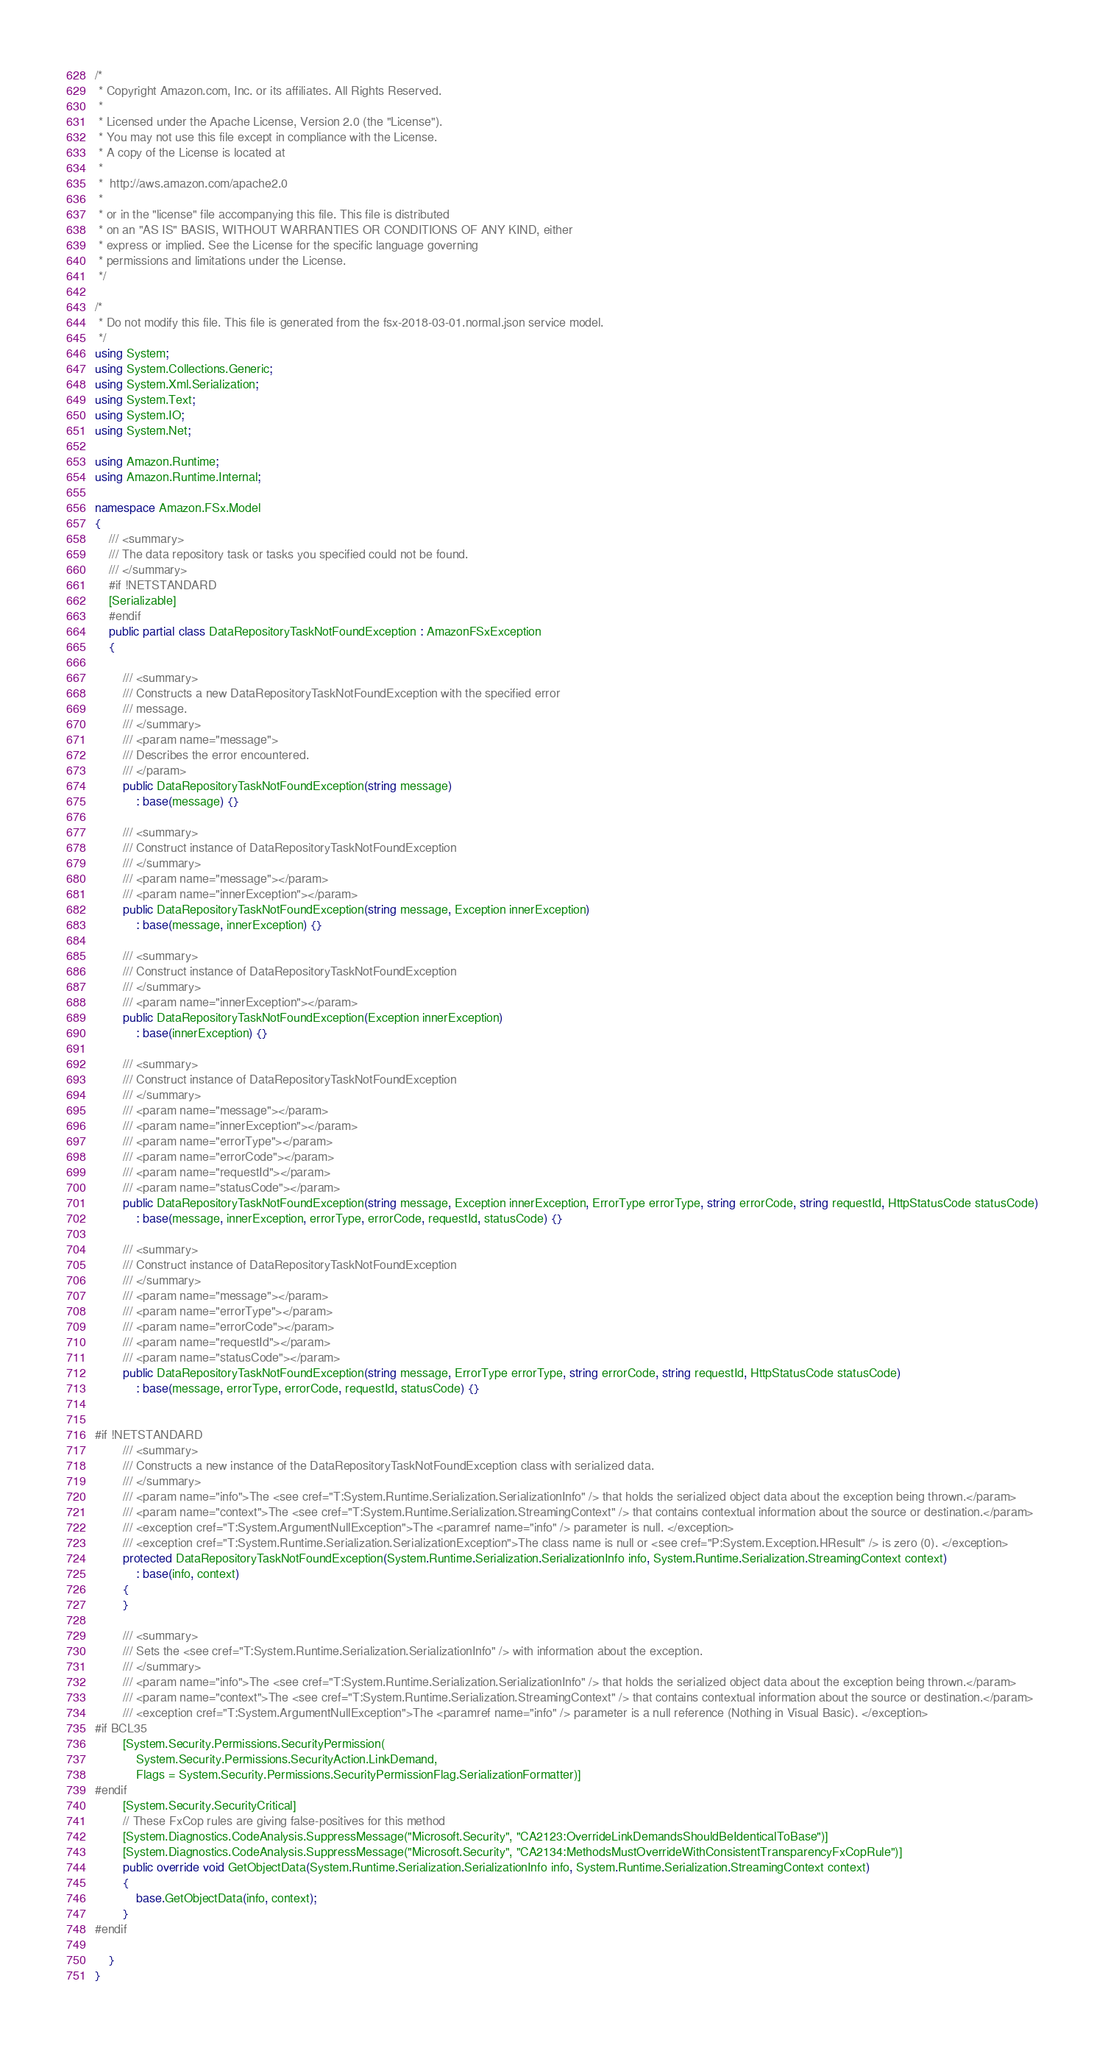Convert code to text. <code><loc_0><loc_0><loc_500><loc_500><_C#_>/*
 * Copyright Amazon.com, Inc. or its affiliates. All Rights Reserved.
 * 
 * Licensed under the Apache License, Version 2.0 (the "License").
 * You may not use this file except in compliance with the License.
 * A copy of the License is located at
 * 
 *  http://aws.amazon.com/apache2.0
 * 
 * or in the "license" file accompanying this file. This file is distributed
 * on an "AS IS" BASIS, WITHOUT WARRANTIES OR CONDITIONS OF ANY KIND, either
 * express or implied. See the License for the specific language governing
 * permissions and limitations under the License.
 */

/*
 * Do not modify this file. This file is generated from the fsx-2018-03-01.normal.json service model.
 */
using System;
using System.Collections.Generic;
using System.Xml.Serialization;
using System.Text;
using System.IO;
using System.Net;

using Amazon.Runtime;
using Amazon.Runtime.Internal;

namespace Amazon.FSx.Model
{
    /// <summary>
    /// The data repository task or tasks you specified could not be found.
    /// </summary>
    #if !NETSTANDARD
    [Serializable]
    #endif
    public partial class DataRepositoryTaskNotFoundException : AmazonFSxException
    {

        /// <summary>
        /// Constructs a new DataRepositoryTaskNotFoundException with the specified error
        /// message.
        /// </summary>
        /// <param name="message">
        /// Describes the error encountered.
        /// </param>
        public DataRepositoryTaskNotFoundException(string message) 
            : base(message) {}

        /// <summary>
        /// Construct instance of DataRepositoryTaskNotFoundException
        /// </summary>
        /// <param name="message"></param>
        /// <param name="innerException"></param>
        public DataRepositoryTaskNotFoundException(string message, Exception innerException) 
            : base(message, innerException) {}

        /// <summary>
        /// Construct instance of DataRepositoryTaskNotFoundException
        /// </summary>
        /// <param name="innerException"></param>
        public DataRepositoryTaskNotFoundException(Exception innerException) 
            : base(innerException) {}

        /// <summary>
        /// Construct instance of DataRepositoryTaskNotFoundException
        /// </summary>
        /// <param name="message"></param>
        /// <param name="innerException"></param>
        /// <param name="errorType"></param>
        /// <param name="errorCode"></param>
        /// <param name="requestId"></param>
        /// <param name="statusCode"></param>
        public DataRepositoryTaskNotFoundException(string message, Exception innerException, ErrorType errorType, string errorCode, string requestId, HttpStatusCode statusCode) 
            : base(message, innerException, errorType, errorCode, requestId, statusCode) {}

        /// <summary>
        /// Construct instance of DataRepositoryTaskNotFoundException
        /// </summary>
        /// <param name="message"></param>
        /// <param name="errorType"></param>
        /// <param name="errorCode"></param>
        /// <param name="requestId"></param>
        /// <param name="statusCode"></param>
        public DataRepositoryTaskNotFoundException(string message, ErrorType errorType, string errorCode, string requestId, HttpStatusCode statusCode) 
            : base(message, errorType, errorCode, requestId, statusCode) {}


#if !NETSTANDARD
        /// <summary>
        /// Constructs a new instance of the DataRepositoryTaskNotFoundException class with serialized data.
        /// </summary>
        /// <param name="info">The <see cref="T:System.Runtime.Serialization.SerializationInfo" /> that holds the serialized object data about the exception being thrown.</param>
        /// <param name="context">The <see cref="T:System.Runtime.Serialization.StreamingContext" /> that contains contextual information about the source or destination.</param>
        /// <exception cref="T:System.ArgumentNullException">The <paramref name="info" /> parameter is null. </exception>
        /// <exception cref="T:System.Runtime.Serialization.SerializationException">The class name is null or <see cref="P:System.Exception.HResult" /> is zero (0). </exception>
        protected DataRepositoryTaskNotFoundException(System.Runtime.Serialization.SerializationInfo info, System.Runtime.Serialization.StreamingContext context)
            : base(info, context)
        {
        }

        /// <summary>
        /// Sets the <see cref="T:System.Runtime.Serialization.SerializationInfo" /> with information about the exception.
        /// </summary>
        /// <param name="info">The <see cref="T:System.Runtime.Serialization.SerializationInfo" /> that holds the serialized object data about the exception being thrown.</param>
        /// <param name="context">The <see cref="T:System.Runtime.Serialization.StreamingContext" /> that contains contextual information about the source or destination.</param>
        /// <exception cref="T:System.ArgumentNullException">The <paramref name="info" /> parameter is a null reference (Nothing in Visual Basic). </exception>
#if BCL35
        [System.Security.Permissions.SecurityPermission(
            System.Security.Permissions.SecurityAction.LinkDemand,
            Flags = System.Security.Permissions.SecurityPermissionFlag.SerializationFormatter)]
#endif
        [System.Security.SecurityCritical]
        // These FxCop rules are giving false-positives for this method
        [System.Diagnostics.CodeAnalysis.SuppressMessage("Microsoft.Security", "CA2123:OverrideLinkDemandsShouldBeIdenticalToBase")]
        [System.Diagnostics.CodeAnalysis.SuppressMessage("Microsoft.Security", "CA2134:MethodsMustOverrideWithConsistentTransparencyFxCopRule")]
        public override void GetObjectData(System.Runtime.Serialization.SerializationInfo info, System.Runtime.Serialization.StreamingContext context)
        {
            base.GetObjectData(info, context);
        }
#endif

    }
}</code> 